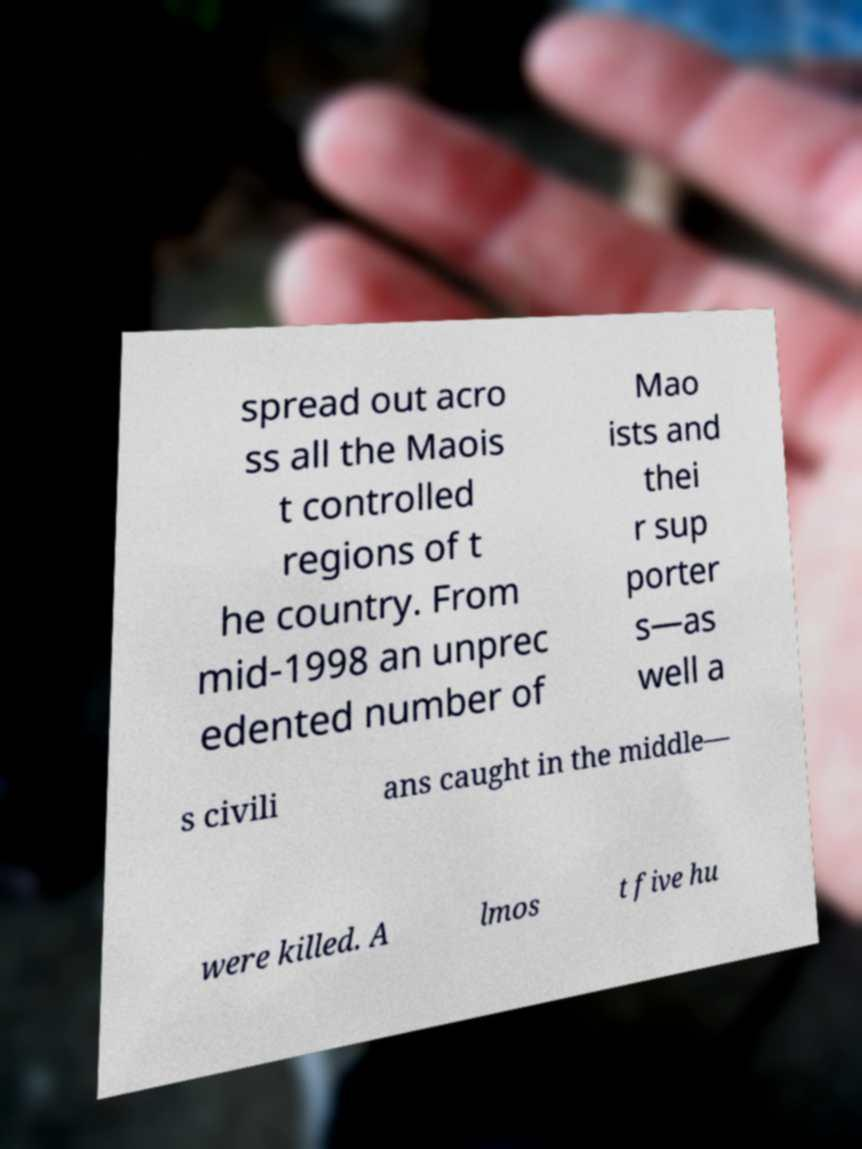Please read and relay the text visible in this image. What does it say? spread out acro ss all the Maois t controlled regions of t he country. From mid-1998 an unprec edented number of Mao ists and thei r sup porter s—as well a s civili ans caught in the middle— were killed. A lmos t five hu 